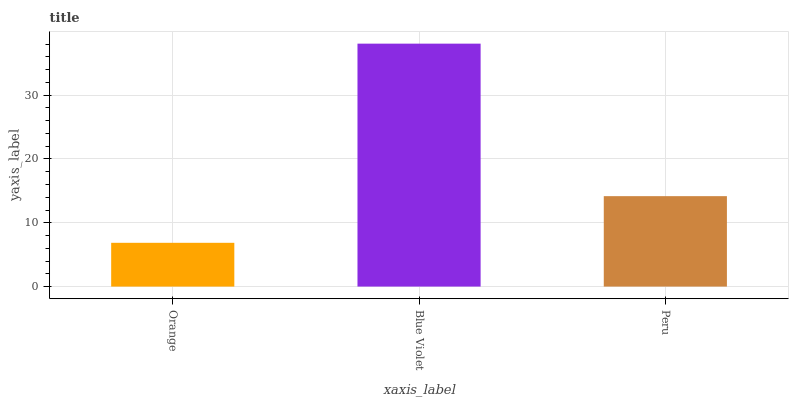Is Orange the minimum?
Answer yes or no. Yes. Is Blue Violet the maximum?
Answer yes or no. Yes. Is Peru the minimum?
Answer yes or no. No. Is Peru the maximum?
Answer yes or no. No. Is Blue Violet greater than Peru?
Answer yes or no. Yes. Is Peru less than Blue Violet?
Answer yes or no. Yes. Is Peru greater than Blue Violet?
Answer yes or no. No. Is Blue Violet less than Peru?
Answer yes or no. No. Is Peru the high median?
Answer yes or no. Yes. Is Peru the low median?
Answer yes or no. Yes. Is Orange the high median?
Answer yes or no. No. Is Orange the low median?
Answer yes or no. No. 